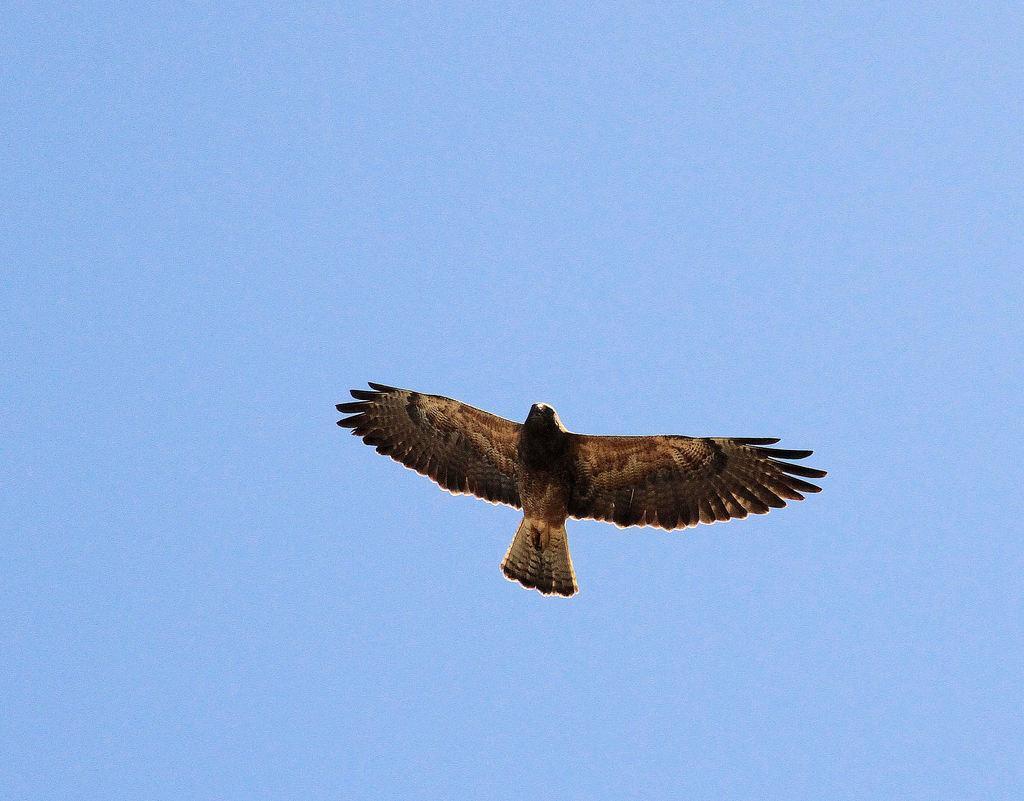How would you summarize this image in a sentence or two? In this image I can see a bird and the bird is in the air. The bird is in brown and cream color, background the sky is in blue color. 